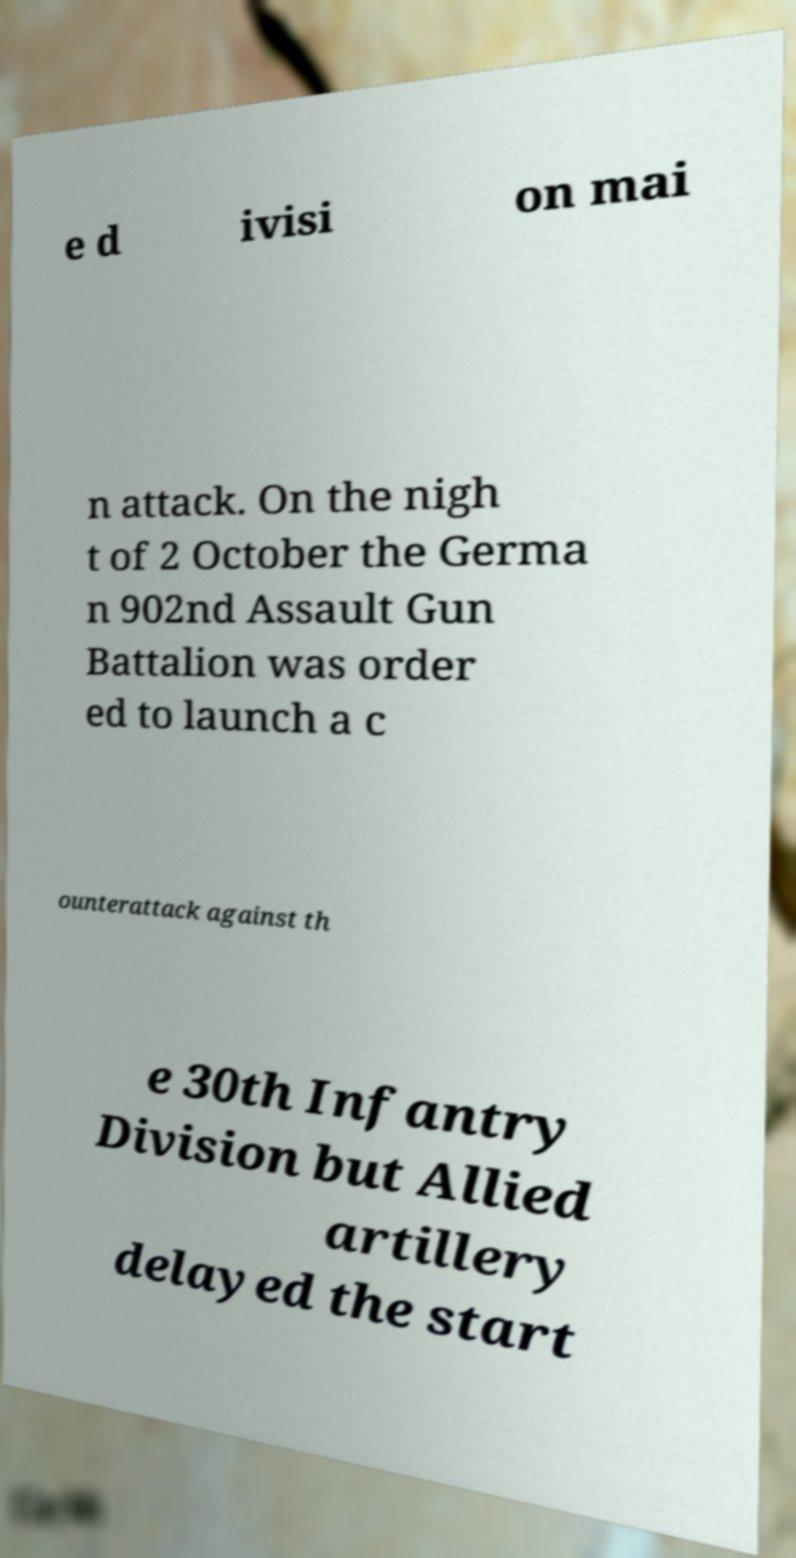Can you accurately transcribe the text from the provided image for me? e d ivisi on mai n attack. On the nigh t of 2 October the Germa n 902nd Assault Gun Battalion was order ed to launch a c ounterattack against th e 30th Infantry Division but Allied artillery delayed the start 